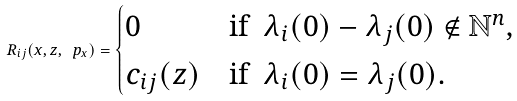Convert formula to latex. <formula><loc_0><loc_0><loc_500><loc_500>R _ { i j } ( x , z , \ p _ { x } ) = \begin{cases} 0 & \text {if \ } \lambda _ { i } ( 0 ) - \lambda _ { j } ( 0 ) \notin \mathbb { N } ^ { n } , \\ c _ { i j } ( z ) & \text {if \ } \lambda _ { i } ( 0 ) = \lambda _ { j } ( 0 ) . \end{cases}</formula> 